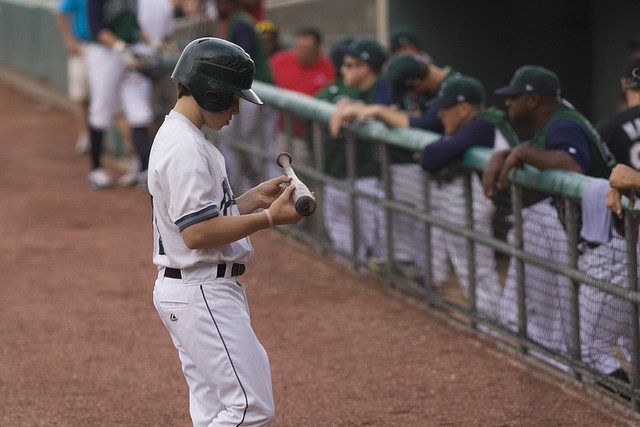Describe the objects in this image and their specific colors. I can see people in gray, darkgray, lightgray, and black tones, people in gray and black tones, people in gray and black tones, people in gray, black, darkgray, and lavender tones, and people in gray and black tones in this image. 